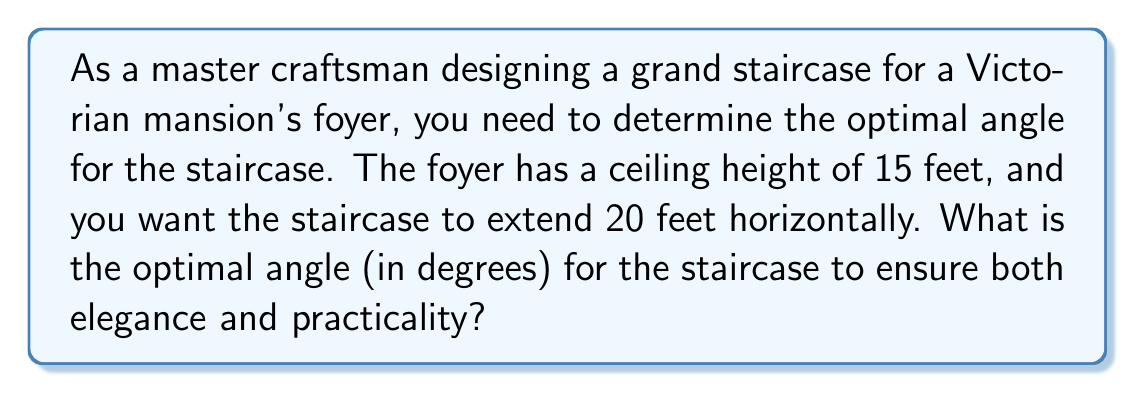Can you answer this question? To solve this problem, we'll use trigonometry to find the angle of the staircase. Let's break it down step-by-step:

1. Visualize the problem:
   [asy]
   import geometry;
   
   size(200);
   
   pair A = (0,0);
   pair B = (20,0);
   pair C = (0,15);
   
   draw(A--B--C--A);
   
   label("15 ft", C--A, W);
   label("20 ft", A--B, S);
   label("$\theta$", A, NE);
   
   draw(rightangle(B,A,C,20));
   [/asy]

2. We have a right triangle where:
   - The adjacent side (horizontal distance) is 20 feet
   - The opposite side (vertical height) is 15 feet
   - We need to find the angle $\theta$

3. The tangent function relates the opposite and adjacent sides to the angle:

   $$\tan(\theta) = \frac{\text{opposite}}{\text{adjacent}} = \frac{15}{20}$$

4. To find $\theta$, we need to use the inverse tangent (arctangent) function:

   $$\theta = \arctan(\frac{15}{20})$$

5. Calculate the result:
   $$\theta = \arctan(0.75) \approx 36.87\text{°}$$

6. Round to the nearest degree for practical application:
   $$\theta \approx 37\text{°}$$

This angle provides a good balance between elegance and practicality for a Victorian grand staircase. It allows for a gentle ascent while making an impressive architectural statement in the foyer.
Answer: The optimal angle for the grand staircase is approximately $37\text{°}$. 